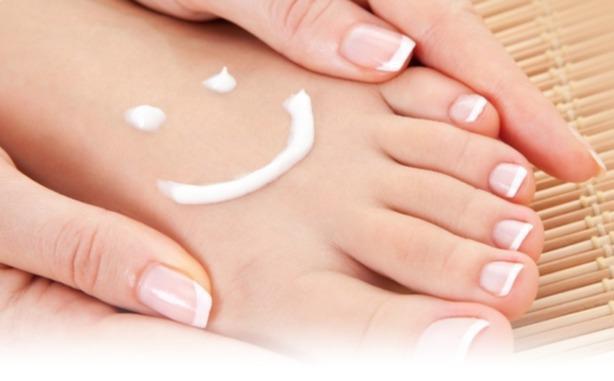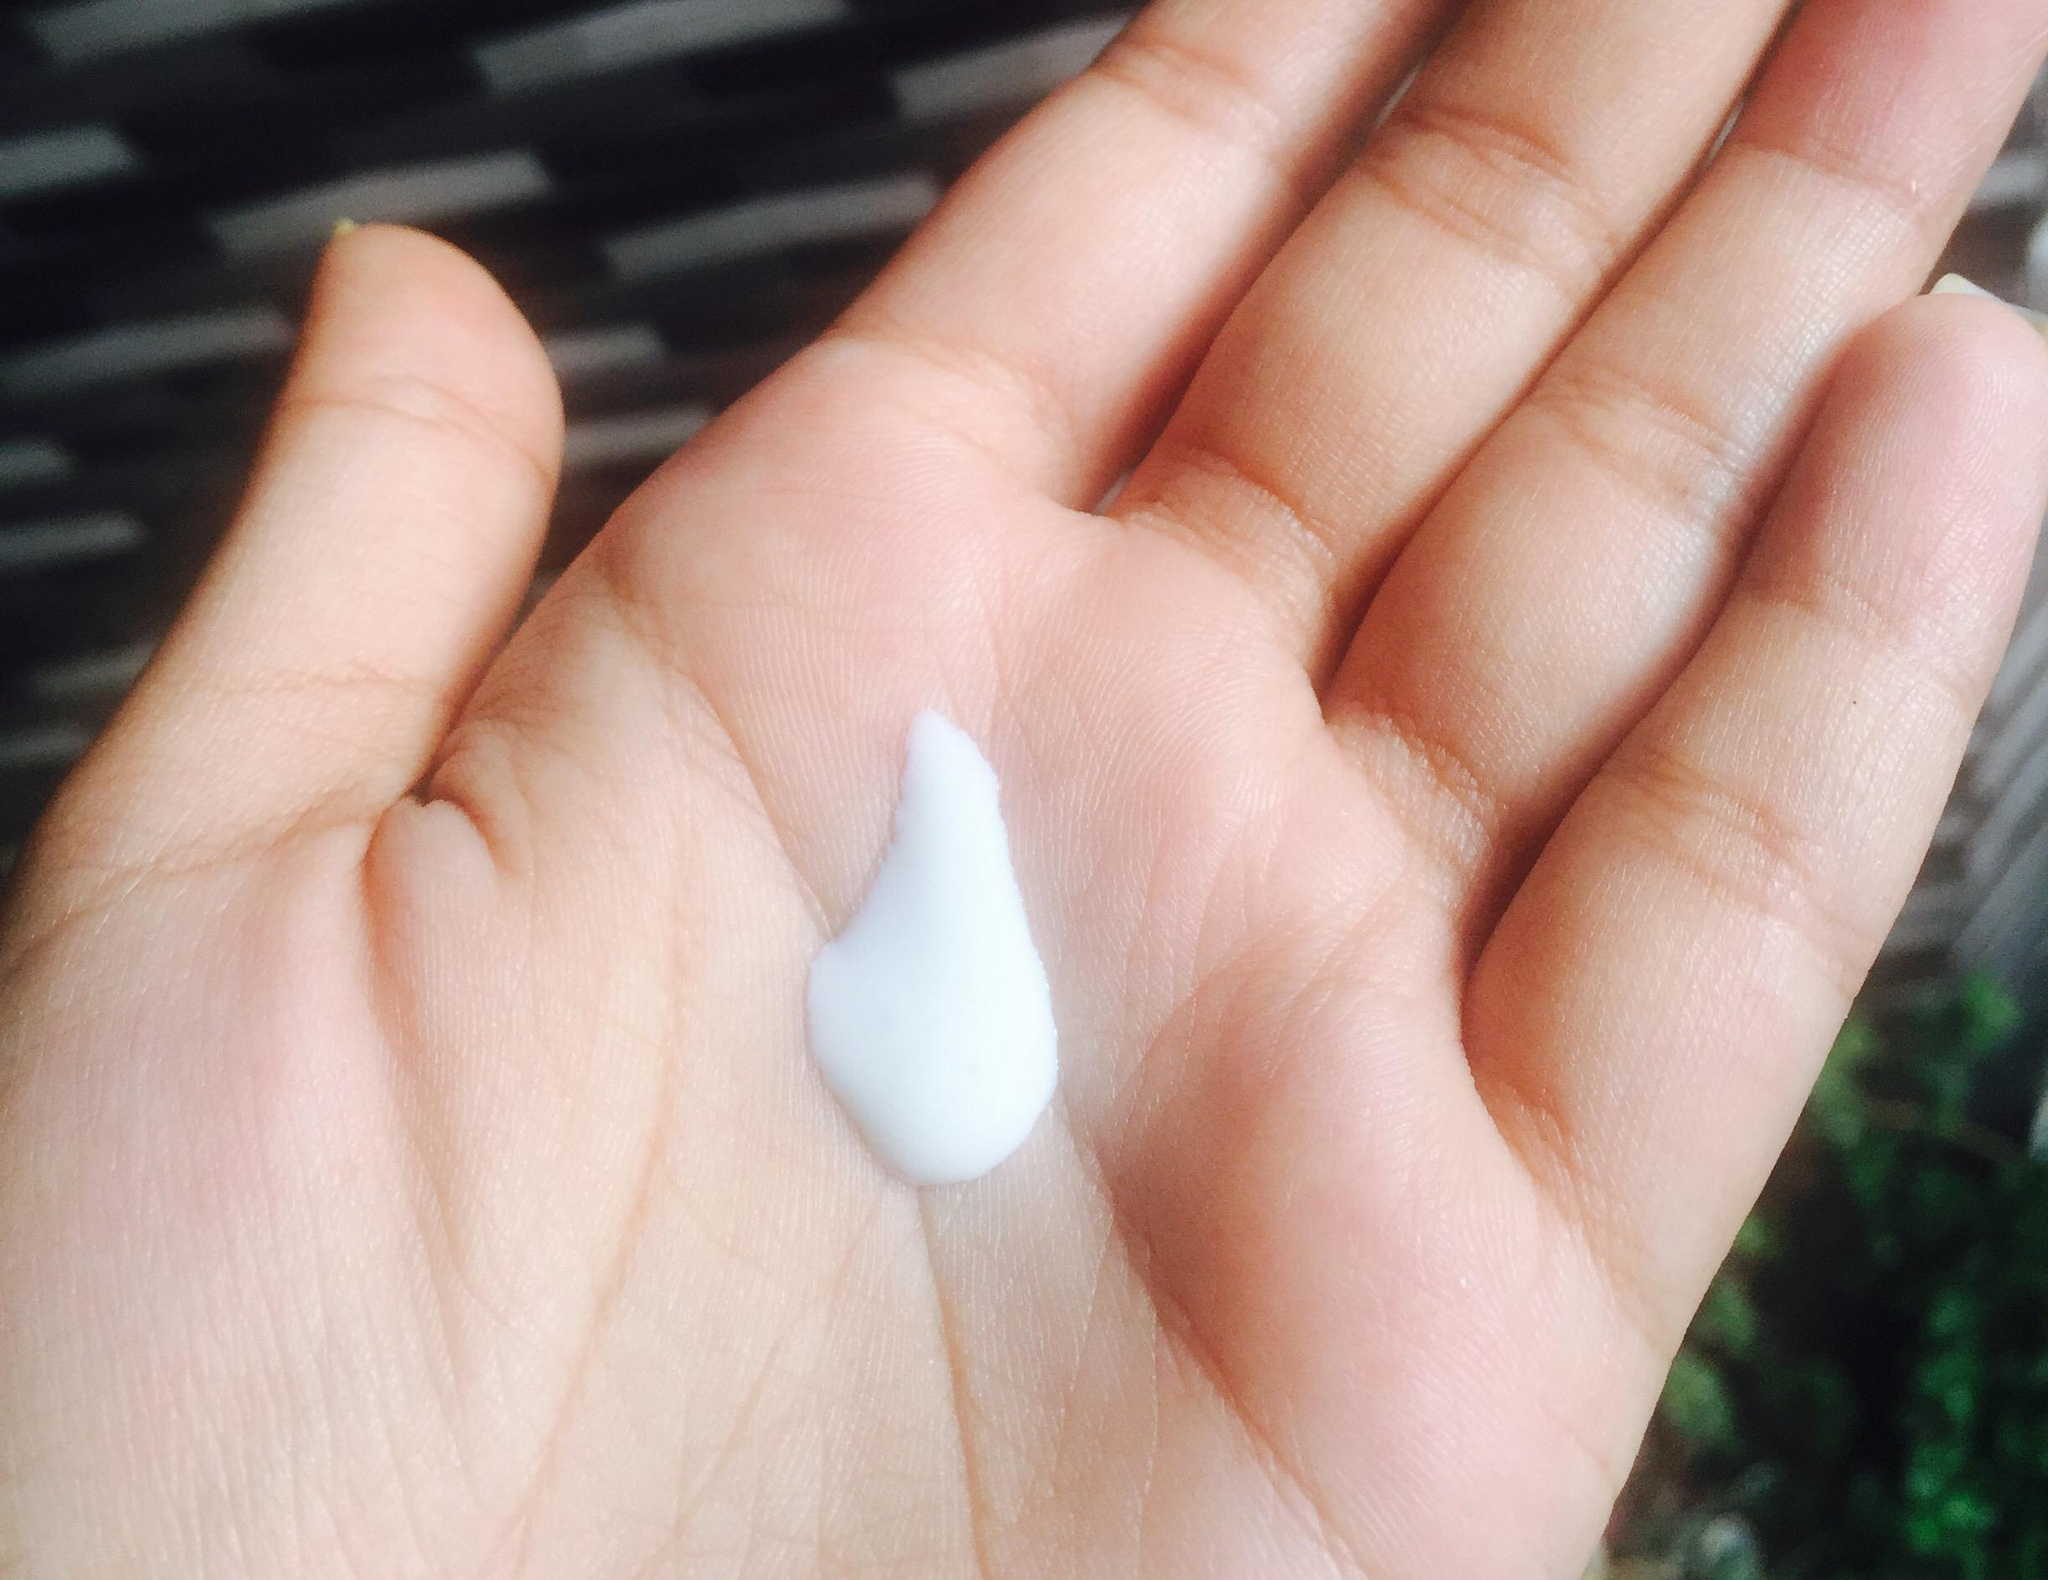The first image is the image on the left, the second image is the image on the right. Considering the images on both sides, is "Both bottles have a pump-style dispenser on top." valid? Answer yes or no. No. The first image is the image on the left, the second image is the image on the right. Examine the images to the left and right. Is the description "There is at most, 1 lotion bottle with a green cap." accurate? Answer yes or no. No. 